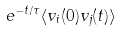<formula> <loc_0><loc_0><loc_500><loc_500>\ e ^ { - t / \tau } \langle v _ { i } ( 0 ) v _ { j } ( t ) \rangle</formula> 